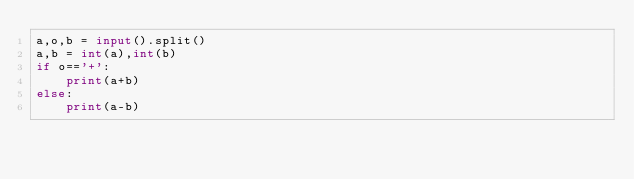Convert code to text. <code><loc_0><loc_0><loc_500><loc_500><_Python_>a,o,b = input().split()
a,b = int(a),int(b)
if o=='+':
    print(a+b)
else:
    print(a-b)</code> 